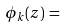Convert formula to latex. <formula><loc_0><loc_0><loc_500><loc_500>\phi _ { k } ( z ) \, = \,</formula> 